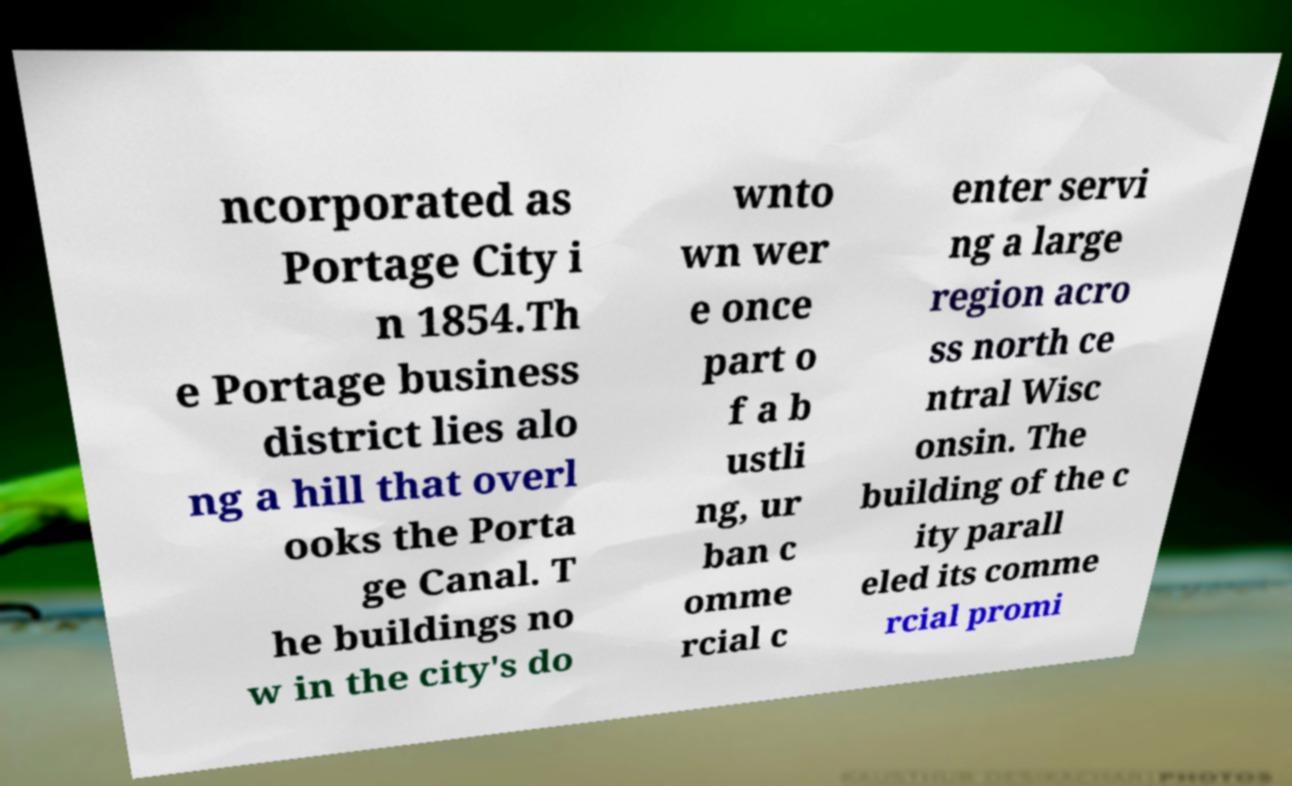Can you accurately transcribe the text from the provided image for me? ncorporated as Portage City i n 1854.Th e Portage business district lies alo ng a hill that overl ooks the Porta ge Canal. T he buildings no w in the city's do wnto wn wer e once part o f a b ustli ng, ur ban c omme rcial c enter servi ng a large region acro ss north ce ntral Wisc onsin. The building of the c ity parall eled its comme rcial promi 